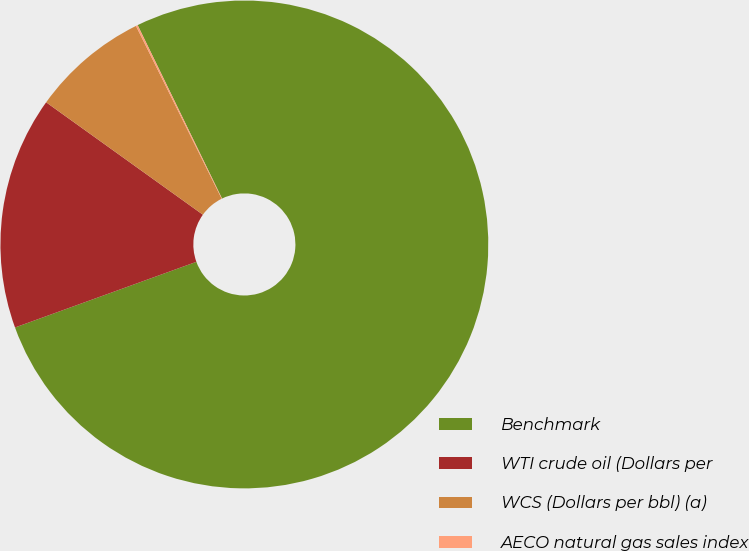<chart> <loc_0><loc_0><loc_500><loc_500><pie_chart><fcel>Benchmark<fcel>WTI crude oil (Dollars per<fcel>WCS (Dollars per bbl) (a)<fcel>AECO natural gas sales index<nl><fcel>76.68%<fcel>15.43%<fcel>7.77%<fcel>0.12%<nl></chart> 